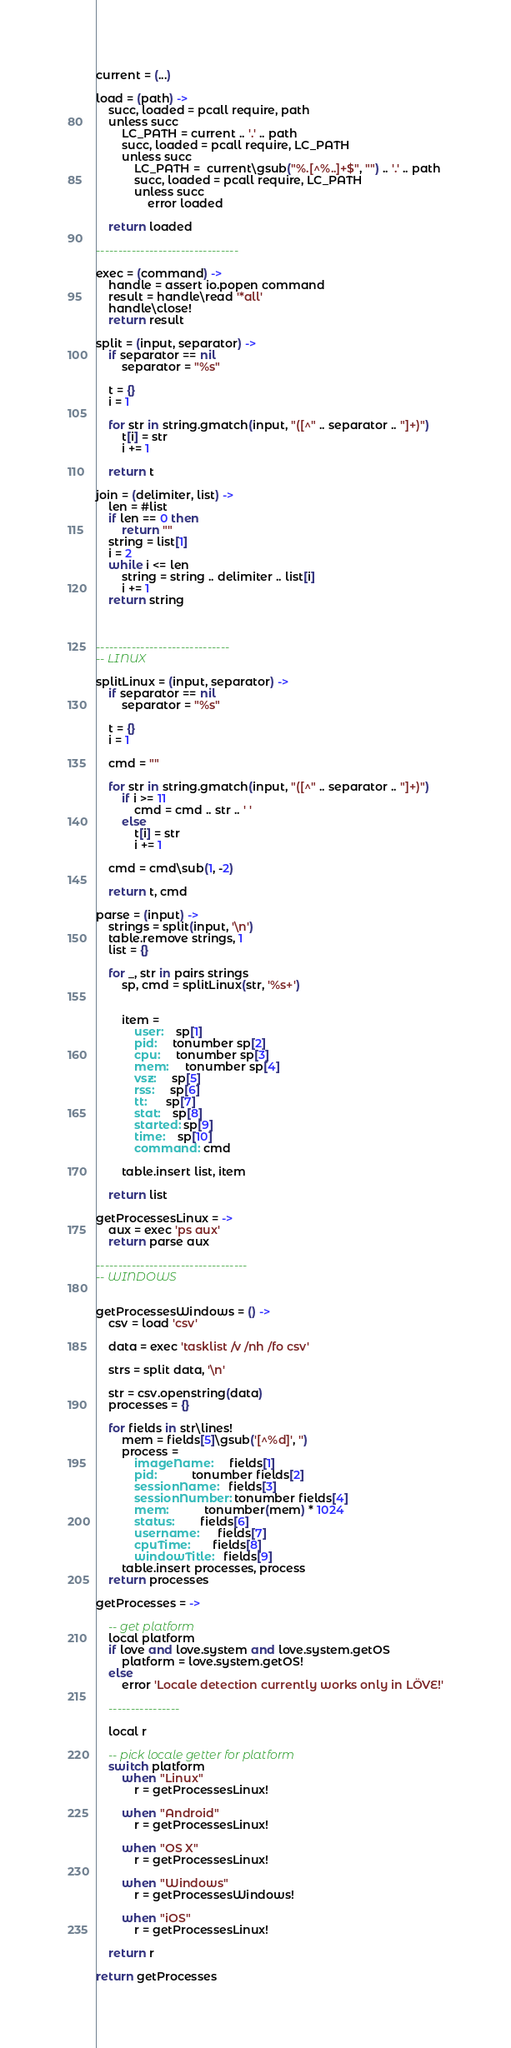<code> <loc_0><loc_0><loc_500><loc_500><_MoonScript_>
current = (...)

load = (path) ->
	succ, loaded = pcall require, path
	unless succ
		LC_PATH = current .. '.' .. path
		succ, loaded = pcall require, LC_PATH
		unless succ
			LC_PATH =  current\gsub("%.[^%..]+$", "") .. '.' .. path
			succ, loaded = pcall require, LC_PATH
			unless succ
				error loaded

	return loaded

--------------------------------

exec = (command) ->
	handle = assert io.popen command
	result = handle\read '*all'
	handle\close!
	return result

split = (input, separator) ->
	if separator == nil
		separator = "%s"

	t = {}
	i = 1

	for str in string.gmatch(input, "([^" .. separator .. "]+)")
		t[i] = str
		i += 1

	return t

join = (delimiter, list) ->
	len = #list
	if len == 0 then
		return "" 
	string = list[1]
	i = 2
	while i <= len
		string = string .. delimiter .. list[i] 
		i += 1
	return string



------------------------------
-- LINUX

splitLinux = (input, separator) ->
	if separator == nil
		separator = "%s"

	t = {}
	i = 1

	cmd = ""

	for str in string.gmatch(input, "([^" .. separator .. "]+)")
		if i >= 11
			cmd = cmd .. str .. ' '
		else
			t[i] = str
			i += 1

	cmd = cmd\sub(1, -2)

	return t, cmd

parse = (input) ->
	strings = split(input, '\n')
	table.remove strings, 1
	list = {}

	for _, str in pairs strings
		sp, cmd = splitLinux(str, '%s+')


		item =
			user:    sp[1]
			pid:     tonumber sp[2]
			cpu:     tonumber sp[3]
			mem:     tonumber sp[4]
			vsz:     sp[5]
			rss:     sp[6]
			tt:      sp[7]
			stat:    sp[8]
			started: sp[9]
			time:    sp[10]
			command: cmd

		table.insert list, item

	return list

getProcessesLinux = ->
	aux = exec 'ps aux'
	return parse aux

----------------------------------
-- WINDOWS


getProcessesWindows = () ->
	csv = load 'csv'

	data = exec 'tasklist /v /nh /fo csv'

	strs = split data, '\n'	

	str = csv.openstring(data)
	processes = {}

	for fields in str\lines!
		mem = fields[5]\gsub('[^%d]', '')
		process = 
			imageName:     fields[1]
			pid:           tonumber fields[2]
			sessionName:   fields[3]
			sessionNumber: tonumber fields[4]
			mem:           tonumber(mem) * 1024
			status:        fields[6]
			username:      fields[7]
			cpuTime:       fields[8]
			windowTitle:   fields[9]
		table.insert processes, process
	return processes

getProcesses = ->

	-- get platform
	local platform
	if love and love.system and love.system.getOS
		platform = love.system.getOS!
	else
		error 'Locale detection currently works only in LÖVE!'

	----------------

	local r

	-- pick locale getter for platform
	switch platform
		when "Linux"
			r = getProcessesLinux!

		when "Android"
			r = getProcessesLinux!

		when "OS X"
			r = getProcessesLinux!

		when "Windows"
			r = getProcessesWindows!

		when "iOS"
			r = getProcessesLinux!

	return r 

return getProcesses
</code> 